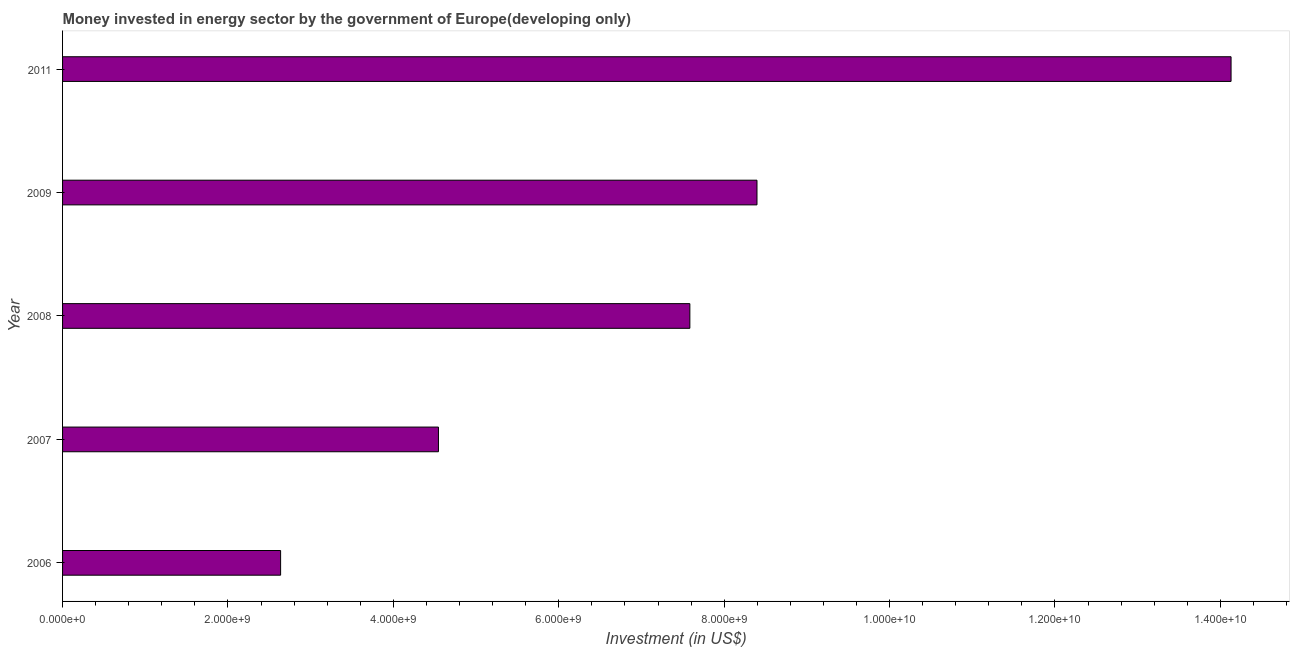Does the graph contain grids?
Your answer should be very brief. No. What is the title of the graph?
Make the answer very short. Money invested in energy sector by the government of Europe(developing only). What is the label or title of the X-axis?
Your response must be concise. Investment (in US$). What is the label or title of the Y-axis?
Your response must be concise. Year. What is the investment in energy in 2008?
Provide a short and direct response. 7.59e+09. Across all years, what is the maximum investment in energy?
Offer a very short reply. 1.41e+1. Across all years, what is the minimum investment in energy?
Provide a short and direct response. 2.64e+09. In which year was the investment in energy minimum?
Provide a short and direct response. 2006. What is the sum of the investment in energy?
Make the answer very short. 3.73e+1. What is the difference between the investment in energy in 2007 and 2008?
Provide a succinct answer. -3.04e+09. What is the average investment in energy per year?
Ensure brevity in your answer.  7.46e+09. What is the median investment in energy?
Make the answer very short. 7.59e+09. In how many years, is the investment in energy greater than 14400000000 US$?
Make the answer very short. 0. Do a majority of the years between 2008 and 2007 (inclusive) have investment in energy greater than 4400000000 US$?
Your response must be concise. No. What is the ratio of the investment in energy in 2007 to that in 2011?
Give a very brief answer. 0.32. Is the difference between the investment in energy in 2006 and 2009 greater than the difference between any two years?
Give a very brief answer. No. What is the difference between the highest and the second highest investment in energy?
Your response must be concise. 5.73e+09. Is the sum of the investment in energy in 2006 and 2011 greater than the maximum investment in energy across all years?
Your response must be concise. Yes. What is the difference between the highest and the lowest investment in energy?
Offer a very short reply. 1.15e+1. In how many years, is the investment in energy greater than the average investment in energy taken over all years?
Provide a short and direct response. 3. Are all the bars in the graph horizontal?
Provide a short and direct response. Yes. What is the difference between two consecutive major ticks on the X-axis?
Make the answer very short. 2.00e+09. What is the Investment (in US$) in 2006?
Your response must be concise. 2.64e+09. What is the Investment (in US$) in 2007?
Ensure brevity in your answer.  4.55e+09. What is the Investment (in US$) in 2008?
Make the answer very short. 7.59e+09. What is the Investment (in US$) in 2009?
Offer a very short reply. 8.40e+09. What is the Investment (in US$) in 2011?
Provide a succinct answer. 1.41e+1. What is the difference between the Investment (in US$) in 2006 and 2007?
Ensure brevity in your answer.  -1.91e+09. What is the difference between the Investment (in US$) in 2006 and 2008?
Keep it short and to the point. -4.95e+09. What is the difference between the Investment (in US$) in 2006 and 2009?
Make the answer very short. -5.76e+09. What is the difference between the Investment (in US$) in 2006 and 2011?
Offer a terse response. -1.15e+1. What is the difference between the Investment (in US$) in 2007 and 2008?
Provide a succinct answer. -3.04e+09. What is the difference between the Investment (in US$) in 2007 and 2009?
Offer a terse response. -3.85e+09. What is the difference between the Investment (in US$) in 2007 and 2011?
Give a very brief answer. -9.58e+09. What is the difference between the Investment (in US$) in 2008 and 2009?
Your answer should be very brief. -8.12e+08. What is the difference between the Investment (in US$) in 2008 and 2011?
Your response must be concise. -6.54e+09. What is the difference between the Investment (in US$) in 2009 and 2011?
Your answer should be compact. -5.73e+09. What is the ratio of the Investment (in US$) in 2006 to that in 2007?
Your answer should be very brief. 0.58. What is the ratio of the Investment (in US$) in 2006 to that in 2008?
Provide a succinct answer. 0.35. What is the ratio of the Investment (in US$) in 2006 to that in 2009?
Your answer should be very brief. 0.31. What is the ratio of the Investment (in US$) in 2006 to that in 2011?
Give a very brief answer. 0.19. What is the ratio of the Investment (in US$) in 2007 to that in 2008?
Your answer should be very brief. 0.6. What is the ratio of the Investment (in US$) in 2007 to that in 2009?
Ensure brevity in your answer.  0.54. What is the ratio of the Investment (in US$) in 2007 to that in 2011?
Provide a short and direct response. 0.32. What is the ratio of the Investment (in US$) in 2008 to that in 2009?
Make the answer very short. 0.9. What is the ratio of the Investment (in US$) in 2008 to that in 2011?
Provide a short and direct response. 0.54. What is the ratio of the Investment (in US$) in 2009 to that in 2011?
Ensure brevity in your answer.  0.59. 